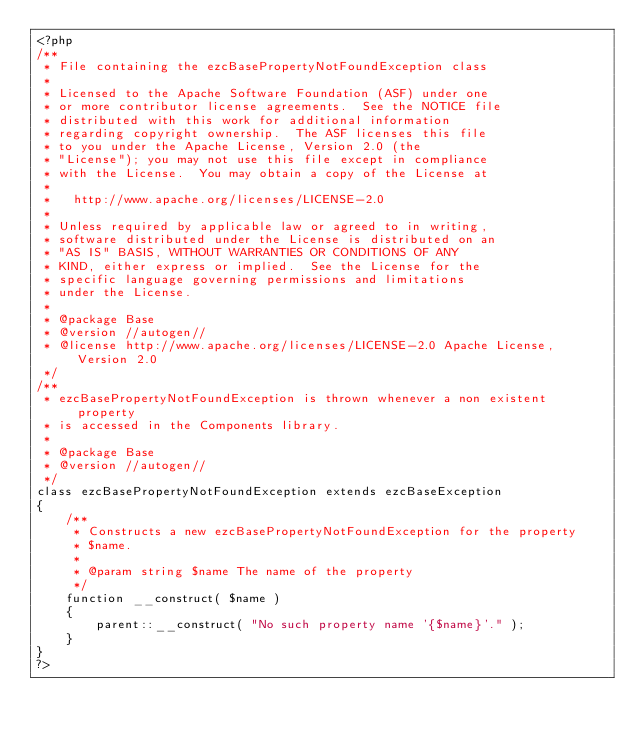Convert code to text. <code><loc_0><loc_0><loc_500><loc_500><_PHP_><?php
/**
 * File containing the ezcBasePropertyNotFoundException class
 *
 * Licensed to the Apache Software Foundation (ASF) under one
 * or more contributor license agreements.  See the NOTICE file
 * distributed with this work for additional information
 * regarding copyright ownership.  The ASF licenses this file
 * to you under the Apache License, Version 2.0 (the
 * "License"); you may not use this file except in compliance
 * with the License.  You may obtain a copy of the License at
 * 
 *   http://www.apache.org/licenses/LICENSE-2.0
 * 
 * Unless required by applicable law or agreed to in writing,
 * software distributed under the License is distributed on an
 * "AS IS" BASIS, WITHOUT WARRANTIES OR CONDITIONS OF ANY
 * KIND, either express or implied.  See the License for the
 * specific language governing permissions and limitations
 * under the License.
 *
 * @package Base
 * @version //autogen//
 * @license http://www.apache.org/licenses/LICENSE-2.0 Apache License, Version 2.0
 */
/**
 * ezcBasePropertyNotFoundException is thrown whenever a non existent property
 * is accessed in the Components library.
 *
 * @package Base
 * @version //autogen//
 */
class ezcBasePropertyNotFoundException extends ezcBaseException
{
    /**
     * Constructs a new ezcBasePropertyNotFoundException for the property
     * $name.
     *
     * @param string $name The name of the property
     */
    function __construct( $name )
    {
        parent::__construct( "No such property name '{$name}'." );
    }
}
?>
</code> 